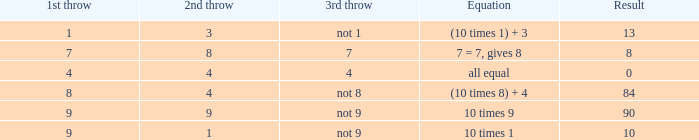What is the result when the 3rd throw is not 8? 84.0. 